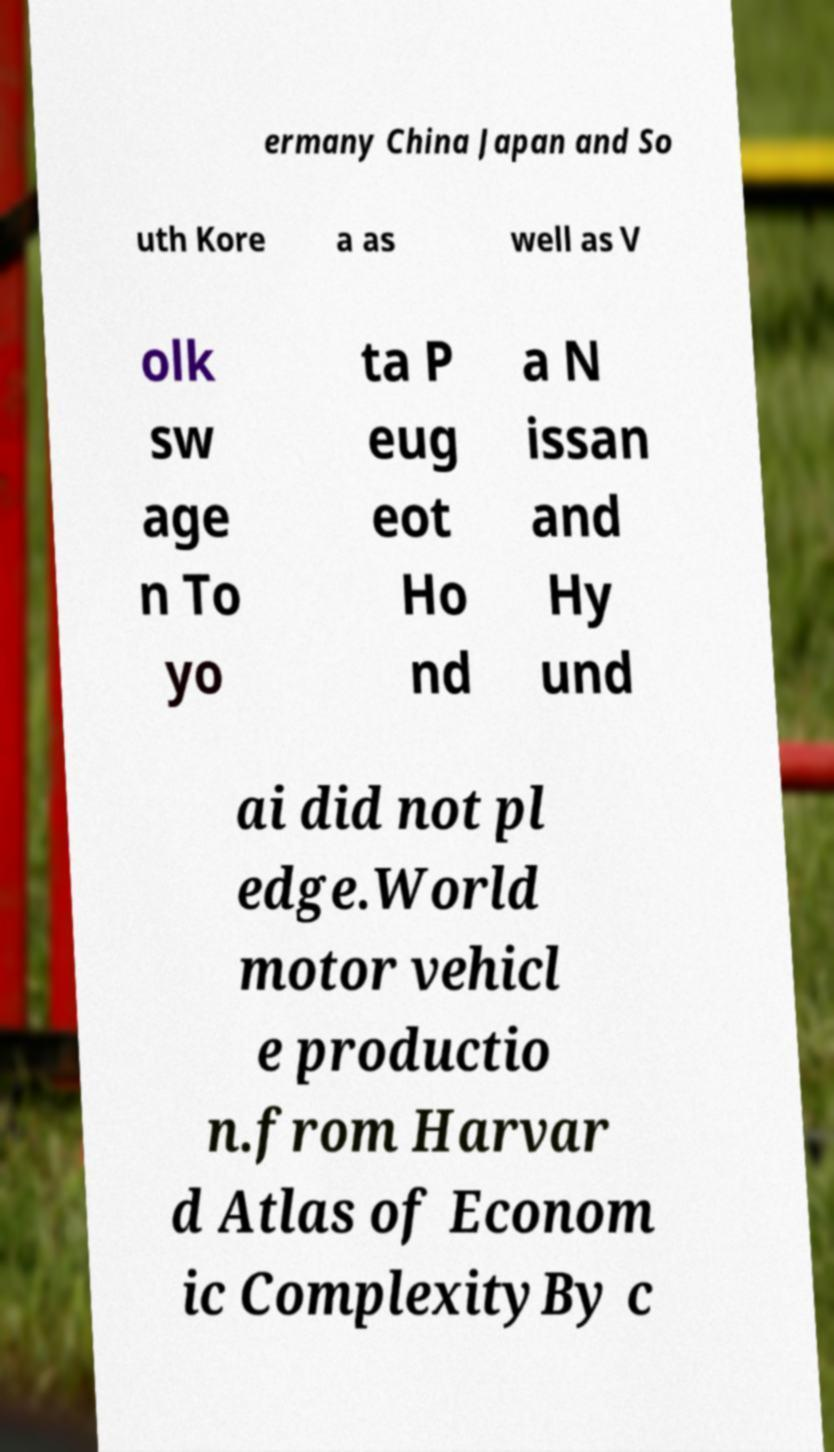Could you assist in decoding the text presented in this image and type it out clearly? ermany China Japan and So uth Kore a as well as V olk sw age n To yo ta P eug eot Ho nd a N issan and Hy und ai did not pl edge.World motor vehicl e productio n.from Harvar d Atlas of Econom ic ComplexityBy c 